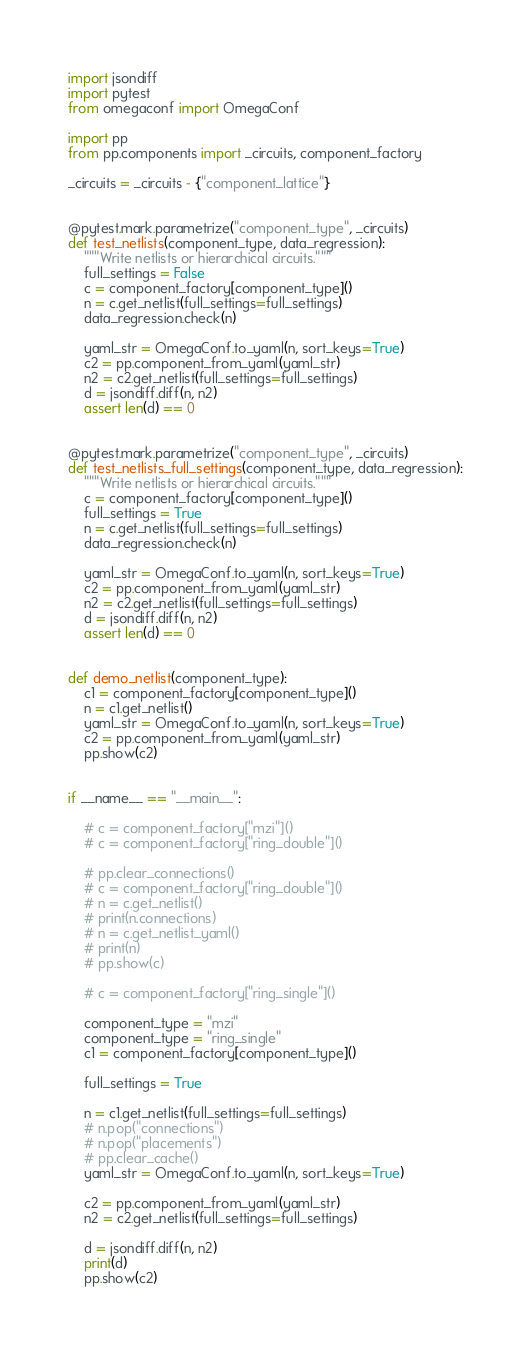<code> <loc_0><loc_0><loc_500><loc_500><_Python_>import jsondiff
import pytest
from omegaconf import OmegaConf

import pp
from pp.components import _circuits, component_factory

_circuits = _circuits - {"component_lattice"}


@pytest.mark.parametrize("component_type", _circuits)
def test_netlists(component_type, data_regression):
    """Write netlists or hierarchical circuits."""
    full_settings = False
    c = component_factory[component_type]()
    n = c.get_netlist(full_settings=full_settings)
    data_regression.check(n)

    yaml_str = OmegaConf.to_yaml(n, sort_keys=True)
    c2 = pp.component_from_yaml(yaml_str)
    n2 = c2.get_netlist(full_settings=full_settings)
    d = jsondiff.diff(n, n2)
    assert len(d) == 0


@pytest.mark.parametrize("component_type", _circuits)
def test_netlists_full_settings(component_type, data_regression):
    """Write netlists or hierarchical circuits."""
    c = component_factory[component_type]()
    full_settings = True
    n = c.get_netlist(full_settings=full_settings)
    data_regression.check(n)

    yaml_str = OmegaConf.to_yaml(n, sort_keys=True)
    c2 = pp.component_from_yaml(yaml_str)
    n2 = c2.get_netlist(full_settings=full_settings)
    d = jsondiff.diff(n, n2)
    assert len(d) == 0


def demo_netlist(component_type):
    c1 = component_factory[component_type]()
    n = c1.get_netlist()
    yaml_str = OmegaConf.to_yaml(n, sort_keys=True)
    c2 = pp.component_from_yaml(yaml_str)
    pp.show(c2)


if __name__ == "__main__":

    # c = component_factory["mzi"]()
    # c = component_factory["ring_double"]()

    # pp.clear_connections()
    # c = component_factory["ring_double"]()
    # n = c.get_netlist()
    # print(n.connections)
    # n = c.get_netlist_yaml()
    # print(n)
    # pp.show(c)

    # c = component_factory["ring_single"]()

    component_type = "mzi"
    component_type = "ring_single"
    c1 = component_factory[component_type]()

    full_settings = True

    n = c1.get_netlist(full_settings=full_settings)
    # n.pop("connections")
    # n.pop("placements")
    # pp.clear_cache()
    yaml_str = OmegaConf.to_yaml(n, sort_keys=True)

    c2 = pp.component_from_yaml(yaml_str)
    n2 = c2.get_netlist(full_settings=full_settings)

    d = jsondiff.diff(n, n2)
    print(d)
    pp.show(c2)
</code> 